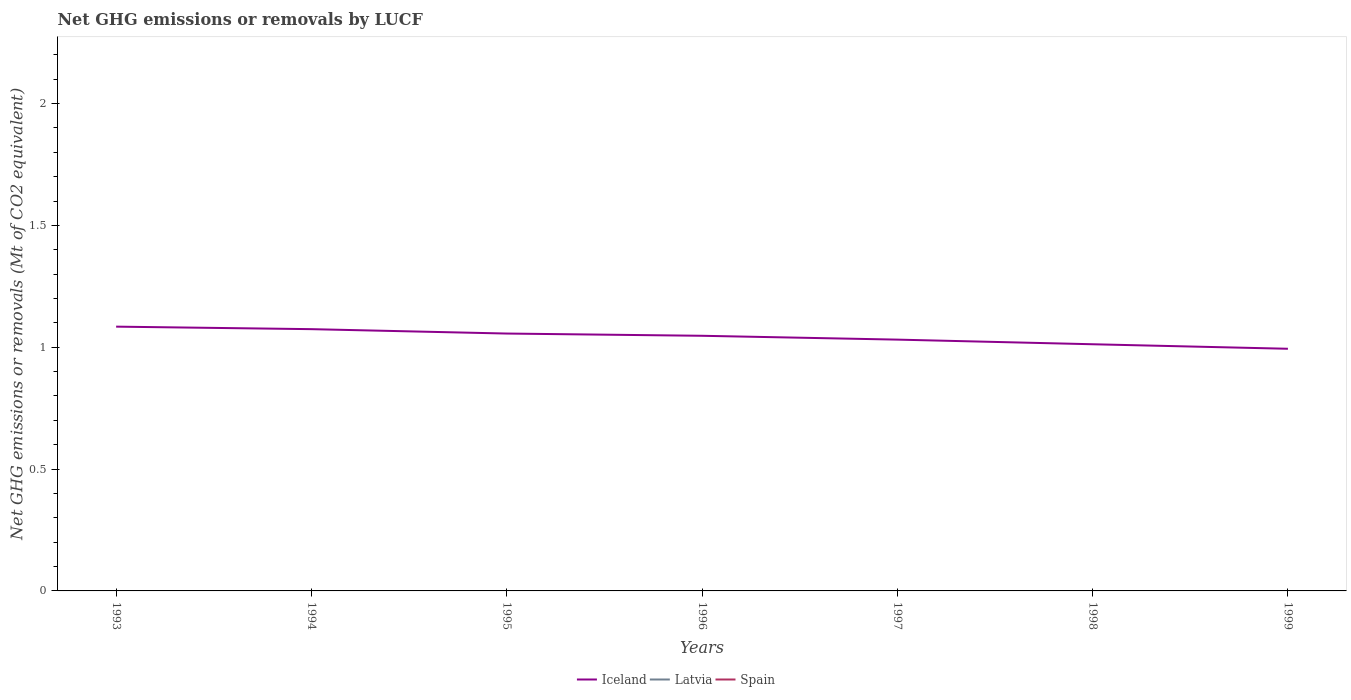Across all years, what is the maximum net GHG emissions or removals by LUCF in Spain?
Give a very brief answer. 0. What is the total net GHG emissions or removals by LUCF in Iceland in the graph?
Make the answer very short. 0.01. What is the difference between the highest and the second highest net GHG emissions or removals by LUCF in Iceland?
Give a very brief answer. 0.09. Is the net GHG emissions or removals by LUCF in Latvia strictly greater than the net GHG emissions or removals by LUCF in Spain over the years?
Ensure brevity in your answer.  No. How many lines are there?
Your response must be concise. 1. How many years are there in the graph?
Make the answer very short. 7. Are the values on the major ticks of Y-axis written in scientific E-notation?
Give a very brief answer. No. Where does the legend appear in the graph?
Your response must be concise. Bottom center. What is the title of the graph?
Give a very brief answer. Net GHG emissions or removals by LUCF. What is the label or title of the Y-axis?
Your response must be concise. Net GHG emissions or removals (Mt of CO2 equivalent). What is the Net GHG emissions or removals (Mt of CO2 equivalent) of Iceland in 1993?
Your answer should be very brief. 1.08. What is the Net GHG emissions or removals (Mt of CO2 equivalent) of Latvia in 1993?
Offer a terse response. 0. What is the Net GHG emissions or removals (Mt of CO2 equivalent) in Spain in 1993?
Give a very brief answer. 0. What is the Net GHG emissions or removals (Mt of CO2 equivalent) of Iceland in 1994?
Your answer should be very brief. 1.07. What is the Net GHG emissions or removals (Mt of CO2 equivalent) in Latvia in 1994?
Your answer should be compact. 0. What is the Net GHG emissions or removals (Mt of CO2 equivalent) of Iceland in 1995?
Your response must be concise. 1.06. What is the Net GHG emissions or removals (Mt of CO2 equivalent) of Latvia in 1995?
Your answer should be compact. 0. What is the Net GHG emissions or removals (Mt of CO2 equivalent) in Iceland in 1996?
Offer a very short reply. 1.05. What is the Net GHG emissions or removals (Mt of CO2 equivalent) in Spain in 1996?
Keep it short and to the point. 0. What is the Net GHG emissions or removals (Mt of CO2 equivalent) of Iceland in 1997?
Make the answer very short. 1.03. What is the Net GHG emissions or removals (Mt of CO2 equivalent) of Iceland in 1998?
Offer a very short reply. 1.01. What is the Net GHG emissions or removals (Mt of CO2 equivalent) in Latvia in 1998?
Keep it short and to the point. 0. What is the Net GHG emissions or removals (Mt of CO2 equivalent) of Iceland in 1999?
Make the answer very short. 0.99. What is the Net GHG emissions or removals (Mt of CO2 equivalent) in Latvia in 1999?
Your answer should be very brief. 0. What is the Net GHG emissions or removals (Mt of CO2 equivalent) in Spain in 1999?
Offer a very short reply. 0. Across all years, what is the maximum Net GHG emissions or removals (Mt of CO2 equivalent) of Iceland?
Offer a very short reply. 1.08. Across all years, what is the minimum Net GHG emissions or removals (Mt of CO2 equivalent) in Iceland?
Your answer should be compact. 0.99. What is the total Net GHG emissions or removals (Mt of CO2 equivalent) in Iceland in the graph?
Provide a short and direct response. 7.3. What is the total Net GHG emissions or removals (Mt of CO2 equivalent) of Latvia in the graph?
Make the answer very short. 0. What is the total Net GHG emissions or removals (Mt of CO2 equivalent) in Spain in the graph?
Your answer should be compact. 0. What is the difference between the Net GHG emissions or removals (Mt of CO2 equivalent) of Iceland in 1993 and that in 1994?
Provide a succinct answer. 0.01. What is the difference between the Net GHG emissions or removals (Mt of CO2 equivalent) in Iceland in 1993 and that in 1995?
Provide a short and direct response. 0.03. What is the difference between the Net GHG emissions or removals (Mt of CO2 equivalent) in Iceland in 1993 and that in 1996?
Offer a terse response. 0.04. What is the difference between the Net GHG emissions or removals (Mt of CO2 equivalent) of Iceland in 1993 and that in 1997?
Your answer should be very brief. 0.05. What is the difference between the Net GHG emissions or removals (Mt of CO2 equivalent) of Iceland in 1993 and that in 1998?
Give a very brief answer. 0.07. What is the difference between the Net GHG emissions or removals (Mt of CO2 equivalent) in Iceland in 1993 and that in 1999?
Your answer should be very brief. 0.09. What is the difference between the Net GHG emissions or removals (Mt of CO2 equivalent) in Iceland in 1994 and that in 1995?
Offer a very short reply. 0.02. What is the difference between the Net GHG emissions or removals (Mt of CO2 equivalent) in Iceland in 1994 and that in 1996?
Offer a very short reply. 0.03. What is the difference between the Net GHG emissions or removals (Mt of CO2 equivalent) in Iceland in 1994 and that in 1997?
Your answer should be very brief. 0.04. What is the difference between the Net GHG emissions or removals (Mt of CO2 equivalent) of Iceland in 1994 and that in 1998?
Offer a very short reply. 0.06. What is the difference between the Net GHG emissions or removals (Mt of CO2 equivalent) in Iceland in 1994 and that in 1999?
Provide a succinct answer. 0.08. What is the difference between the Net GHG emissions or removals (Mt of CO2 equivalent) in Iceland in 1995 and that in 1996?
Give a very brief answer. 0.01. What is the difference between the Net GHG emissions or removals (Mt of CO2 equivalent) in Iceland in 1995 and that in 1997?
Make the answer very short. 0.02. What is the difference between the Net GHG emissions or removals (Mt of CO2 equivalent) in Iceland in 1995 and that in 1998?
Provide a short and direct response. 0.04. What is the difference between the Net GHG emissions or removals (Mt of CO2 equivalent) in Iceland in 1995 and that in 1999?
Make the answer very short. 0.06. What is the difference between the Net GHG emissions or removals (Mt of CO2 equivalent) of Iceland in 1996 and that in 1997?
Give a very brief answer. 0.02. What is the difference between the Net GHG emissions or removals (Mt of CO2 equivalent) of Iceland in 1996 and that in 1998?
Provide a short and direct response. 0.03. What is the difference between the Net GHG emissions or removals (Mt of CO2 equivalent) of Iceland in 1996 and that in 1999?
Provide a short and direct response. 0.05. What is the difference between the Net GHG emissions or removals (Mt of CO2 equivalent) of Iceland in 1997 and that in 1998?
Provide a short and direct response. 0.02. What is the difference between the Net GHG emissions or removals (Mt of CO2 equivalent) in Iceland in 1997 and that in 1999?
Provide a succinct answer. 0.04. What is the difference between the Net GHG emissions or removals (Mt of CO2 equivalent) of Iceland in 1998 and that in 1999?
Offer a very short reply. 0.02. What is the average Net GHG emissions or removals (Mt of CO2 equivalent) in Iceland per year?
Keep it short and to the point. 1.04. What is the average Net GHG emissions or removals (Mt of CO2 equivalent) in Spain per year?
Offer a very short reply. 0. What is the ratio of the Net GHG emissions or removals (Mt of CO2 equivalent) in Iceland in 1993 to that in 1994?
Your response must be concise. 1.01. What is the ratio of the Net GHG emissions or removals (Mt of CO2 equivalent) of Iceland in 1993 to that in 1995?
Make the answer very short. 1.03. What is the ratio of the Net GHG emissions or removals (Mt of CO2 equivalent) of Iceland in 1993 to that in 1996?
Your answer should be very brief. 1.04. What is the ratio of the Net GHG emissions or removals (Mt of CO2 equivalent) of Iceland in 1993 to that in 1997?
Offer a very short reply. 1.05. What is the ratio of the Net GHG emissions or removals (Mt of CO2 equivalent) of Iceland in 1993 to that in 1998?
Provide a succinct answer. 1.07. What is the ratio of the Net GHG emissions or removals (Mt of CO2 equivalent) of Iceland in 1993 to that in 1999?
Give a very brief answer. 1.09. What is the ratio of the Net GHG emissions or removals (Mt of CO2 equivalent) in Iceland in 1994 to that in 1995?
Offer a very short reply. 1.02. What is the ratio of the Net GHG emissions or removals (Mt of CO2 equivalent) of Iceland in 1994 to that in 1996?
Provide a succinct answer. 1.03. What is the ratio of the Net GHG emissions or removals (Mt of CO2 equivalent) of Iceland in 1994 to that in 1997?
Your response must be concise. 1.04. What is the ratio of the Net GHG emissions or removals (Mt of CO2 equivalent) of Iceland in 1994 to that in 1998?
Your answer should be compact. 1.06. What is the ratio of the Net GHG emissions or removals (Mt of CO2 equivalent) of Iceland in 1994 to that in 1999?
Ensure brevity in your answer.  1.08. What is the ratio of the Net GHG emissions or removals (Mt of CO2 equivalent) in Iceland in 1995 to that in 1996?
Your answer should be compact. 1.01. What is the ratio of the Net GHG emissions or removals (Mt of CO2 equivalent) of Iceland in 1995 to that in 1997?
Ensure brevity in your answer.  1.02. What is the ratio of the Net GHG emissions or removals (Mt of CO2 equivalent) of Iceland in 1995 to that in 1998?
Offer a terse response. 1.04. What is the ratio of the Net GHG emissions or removals (Mt of CO2 equivalent) of Iceland in 1995 to that in 1999?
Provide a succinct answer. 1.06. What is the ratio of the Net GHG emissions or removals (Mt of CO2 equivalent) of Iceland in 1996 to that in 1997?
Give a very brief answer. 1.02. What is the ratio of the Net GHG emissions or removals (Mt of CO2 equivalent) of Iceland in 1996 to that in 1998?
Provide a succinct answer. 1.03. What is the ratio of the Net GHG emissions or removals (Mt of CO2 equivalent) in Iceland in 1996 to that in 1999?
Offer a very short reply. 1.05. What is the ratio of the Net GHG emissions or removals (Mt of CO2 equivalent) in Iceland in 1997 to that in 1998?
Offer a very short reply. 1.02. What is the ratio of the Net GHG emissions or removals (Mt of CO2 equivalent) in Iceland in 1997 to that in 1999?
Your response must be concise. 1.04. What is the ratio of the Net GHG emissions or removals (Mt of CO2 equivalent) of Iceland in 1998 to that in 1999?
Make the answer very short. 1.02. What is the difference between the highest and the second highest Net GHG emissions or removals (Mt of CO2 equivalent) of Iceland?
Make the answer very short. 0.01. What is the difference between the highest and the lowest Net GHG emissions or removals (Mt of CO2 equivalent) of Iceland?
Offer a very short reply. 0.09. 